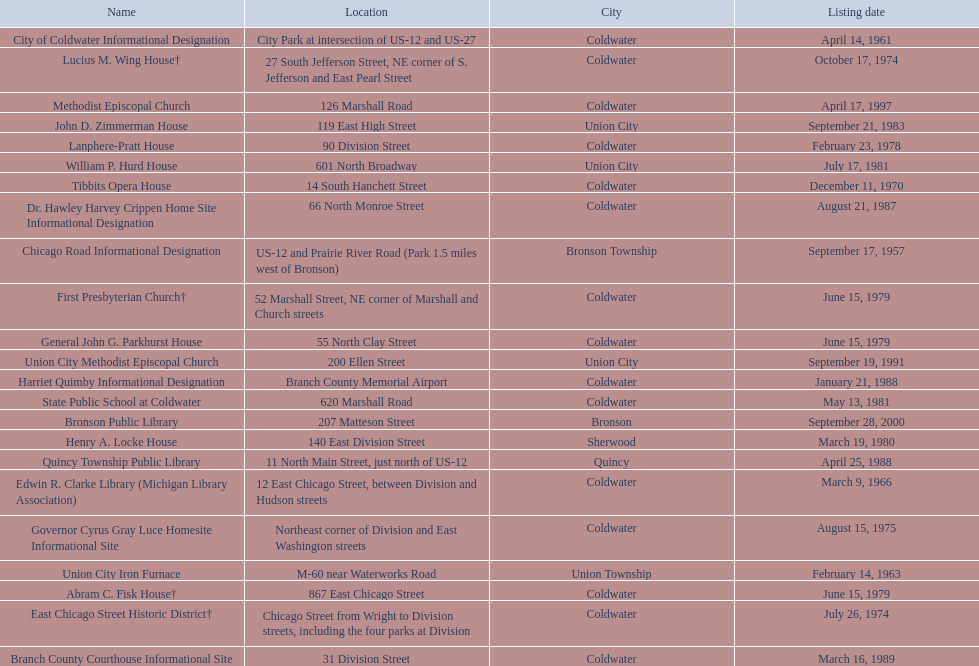In branch co. mi what historic sites are located on a near a highway? Chicago Road Informational Designation, City of Coldwater Informational Designation, Quincy Township Public Library, Union City Iron Furnace. Of the historic sites ins branch co. near highways, which ones are near only us highways? Chicago Road Informational Designation, City of Coldwater Informational Designation, Quincy Township Public Library. Which historical sites in branch co. are near only us highways and are not a building? Chicago Road Informational Designation, City of Coldwater Informational Designation. Which non-building historical sites in branch county near a us highways is closest to bronson? Chicago Road Informational Designation. 